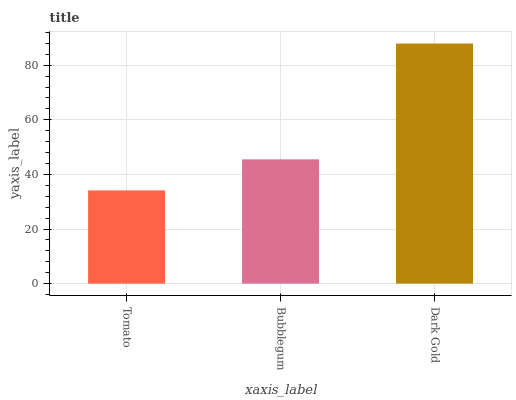Is Tomato the minimum?
Answer yes or no. Yes. Is Dark Gold the maximum?
Answer yes or no. Yes. Is Bubblegum the minimum?
Answer yes or no. No. Is Bubblegum the maximum?
Answer yes or no. No. Is Bubblegum greater than Tomato?
Answer yes or no. Yes. Is Tomato less than Bubblegum?
Answer yes or no. Yes. Is Tomato greater than Bubblegum?
Answer yes or no. No. Is Bubblegum less than Tomato?
Answer yes or no. No. Is Bubblegum the high median?
Answer yes or no. Yes. Is Bubblegum the low median?
Answer yes or no. Yes. Is Tomato the high median?
Answer yes or no. No. Is Tomato the low median?
Answer yes or no. No. 